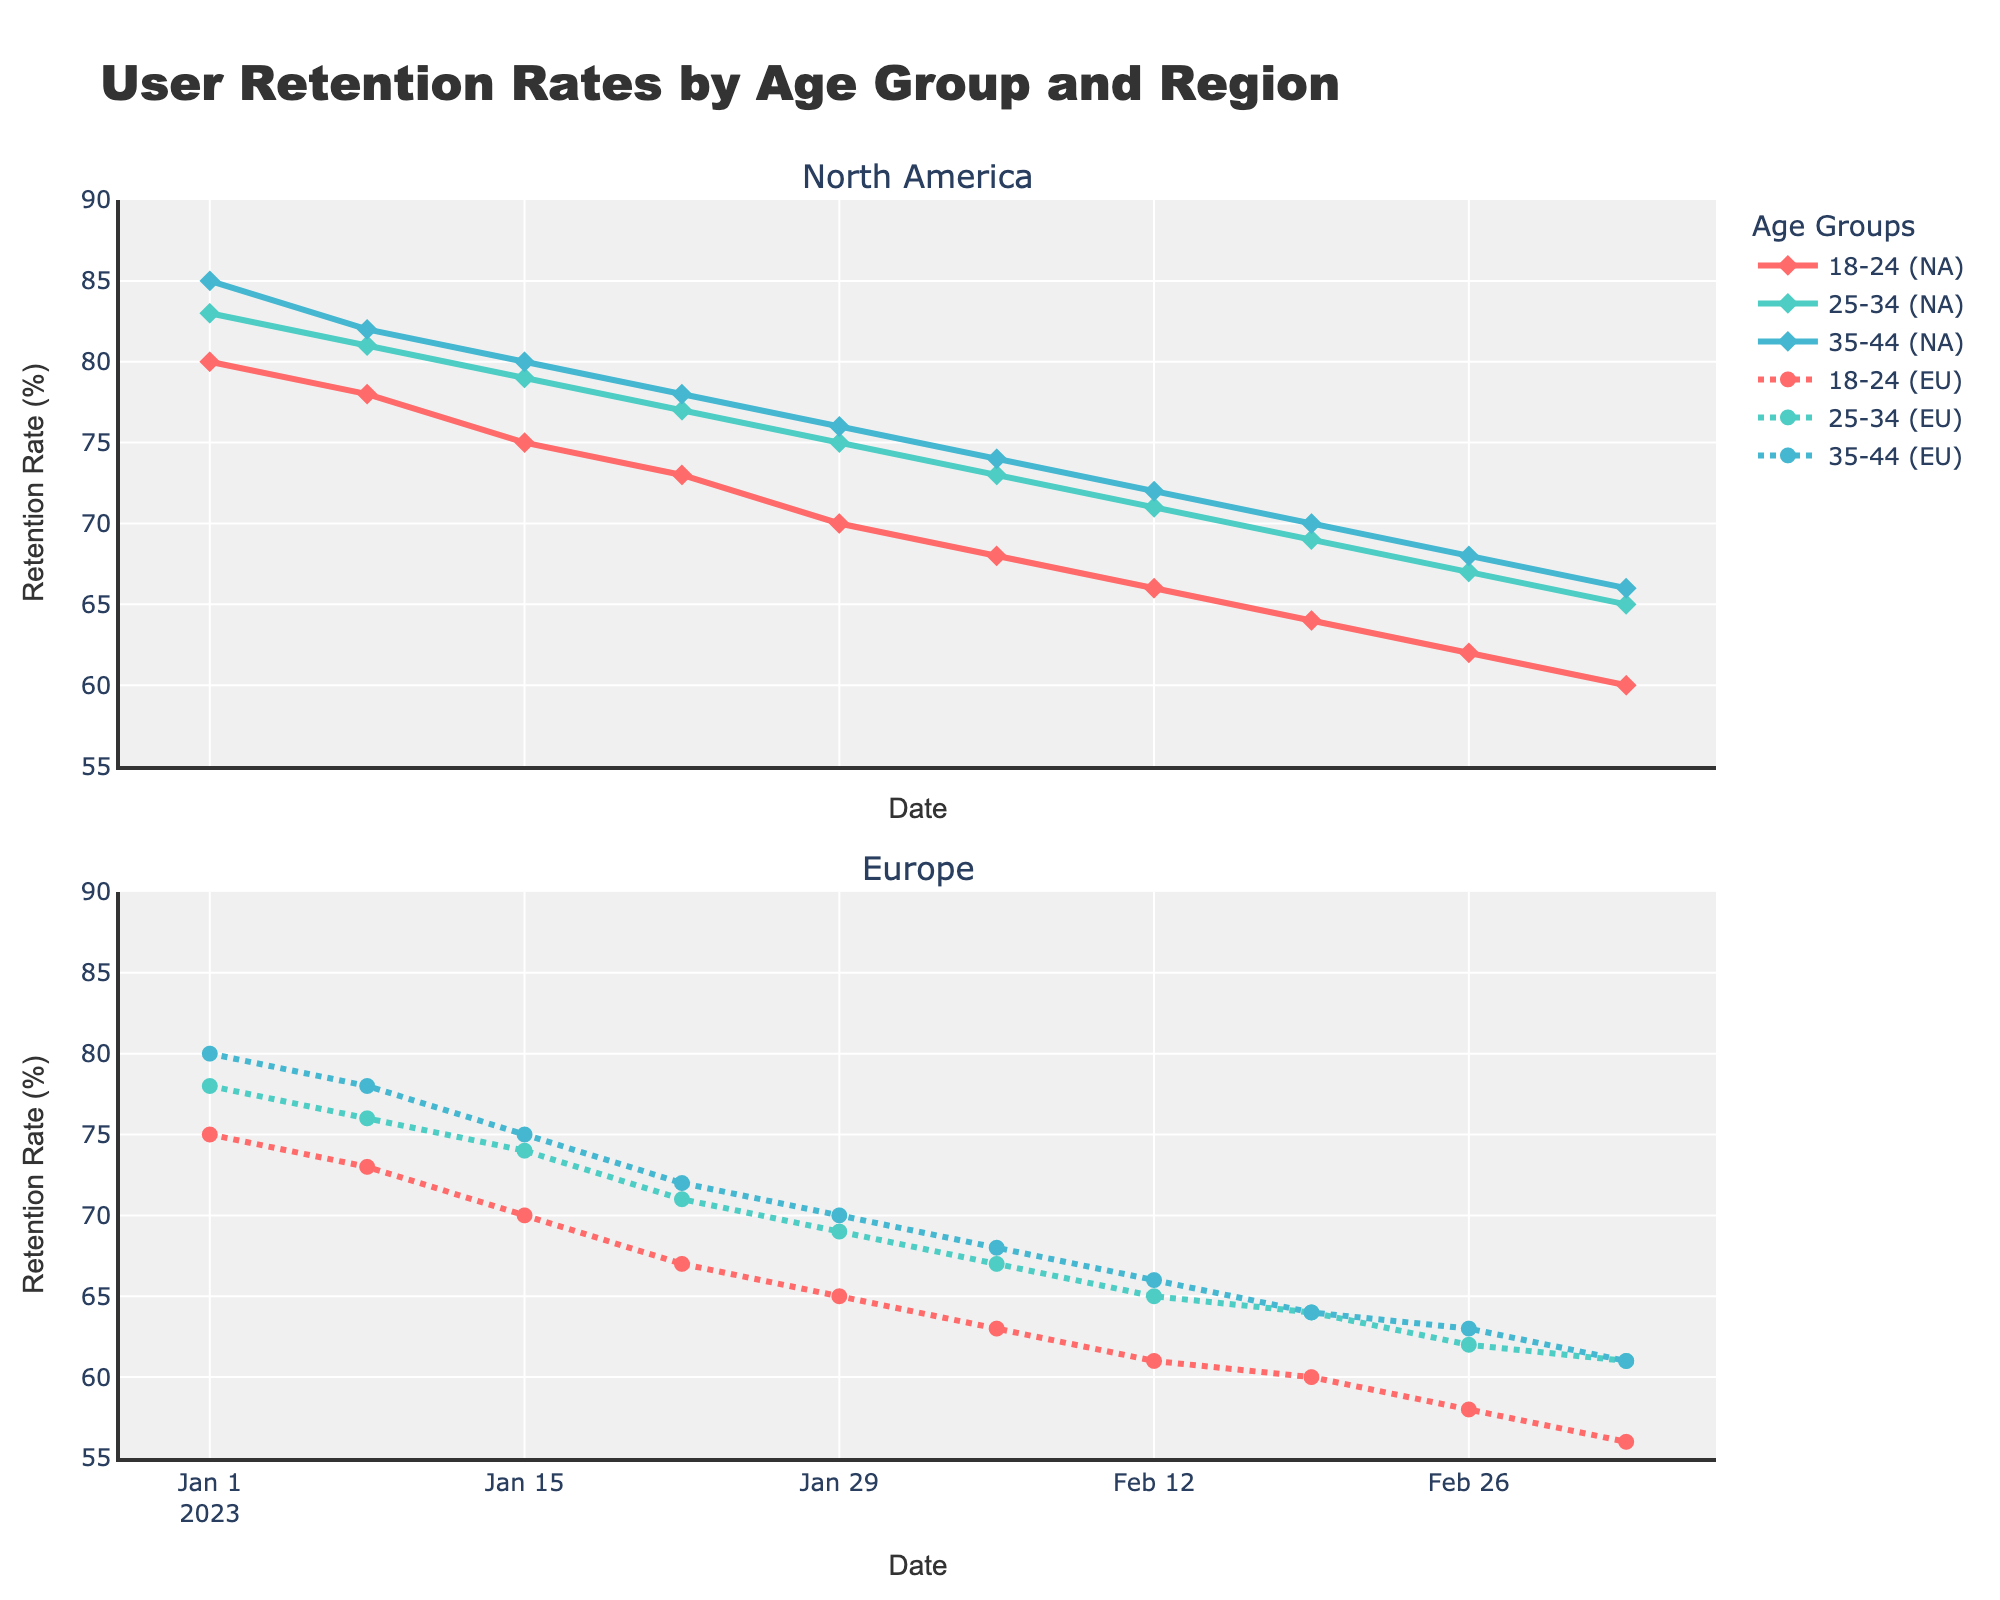What's the title of the plot? The title of the plot is located at the top center of the figure. It provides an overview of what the figure represents. By looking at the title text, you can read the full title.
Answer: User Retention Rates by Age Group and Region Which age group in North America has the highest retention rate on March 5th, 2023? By checking the plot for North America on the date March 5th, 2023, the lines corresponding to different age groups can be observed. The highest retention rate among these lines marks the age group with the maximum retention rate.
Answer: Age Group 35-44 On which date is the retention rate closest between Age Group 18-24 (Europe) and Age Group 18-24 (North America)? To determine this, you need to visually inspect the plots for Europe and North America for Age Group 18-24. Find the date where the lines for these two segments are closest to each other in value.
Answer: 2023-01-01 What is the retention rate difference between Age Group 25-34 (Europe) and Age Group 25-34 (North America) on February 19th, 2023? Locate February 19th, 2023 on the plot and compare the retention rates for Age Group 25-34 in Europe and North America. Subtract the smaller value from the larger value to get the difference.
Answer: 5% Which age group in Europe shows the most significant drop in retention rate from the beginning to the end of the time period? Observe the retention rate at the start and the end of the period for each age group in Europe. Calculate the difference between these values for each age group. Compare these differences to find the one with the largest drop.
Answer: Age Group 35-44 During which week did Age Group 18-24 in Europe experience the largest decrease in retention rate? By examining the plot for Europe and observing the weekly retention rates for Age Group 18-24, find the week where the difference between consecutive weeks is the largest.
Answer: 2023-01-15 to 2023-01-22 What is the average retention rate for Age Group 25-34 (North America) over the time period? Sum all retention rates for Age Group 25-34 (North America) over the given dates and divide by the number of data points to get the average retention rate.
Answer: 74.4 For Age Group 35-44 (North America), on which dates do the retention rates intersect or become equal with those of any age group in Europe? Look at the intersections in the plot or points where retention rates of Age Group 35-44 (North America) match any of the retention rates from the age groups in Europe. Note the dates when they intersect.
Answer: 2023-02-26 Which region has a more consistent retention rate for Age Group 25-34 throughout the plot? Compare the variability or fluctuations in the retention rate of Age Group 25-34 between North America and Europe. Assess which plot shows fewer fluctuations or changes over time.
Answer: North America 